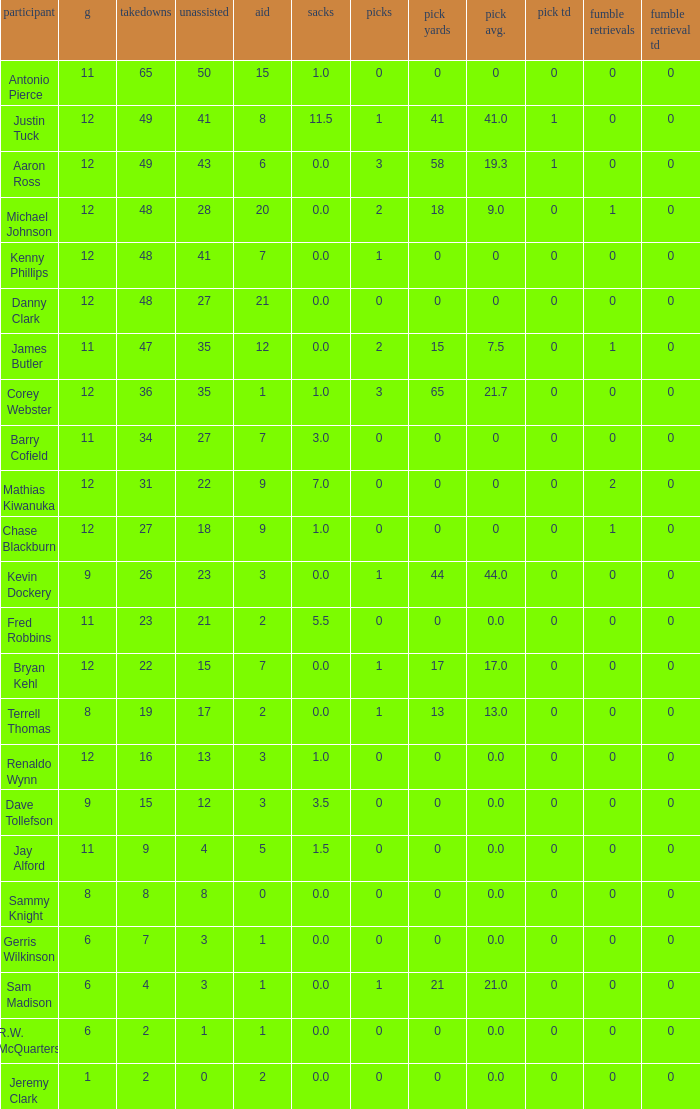Name the least fum rec td 0.0. 